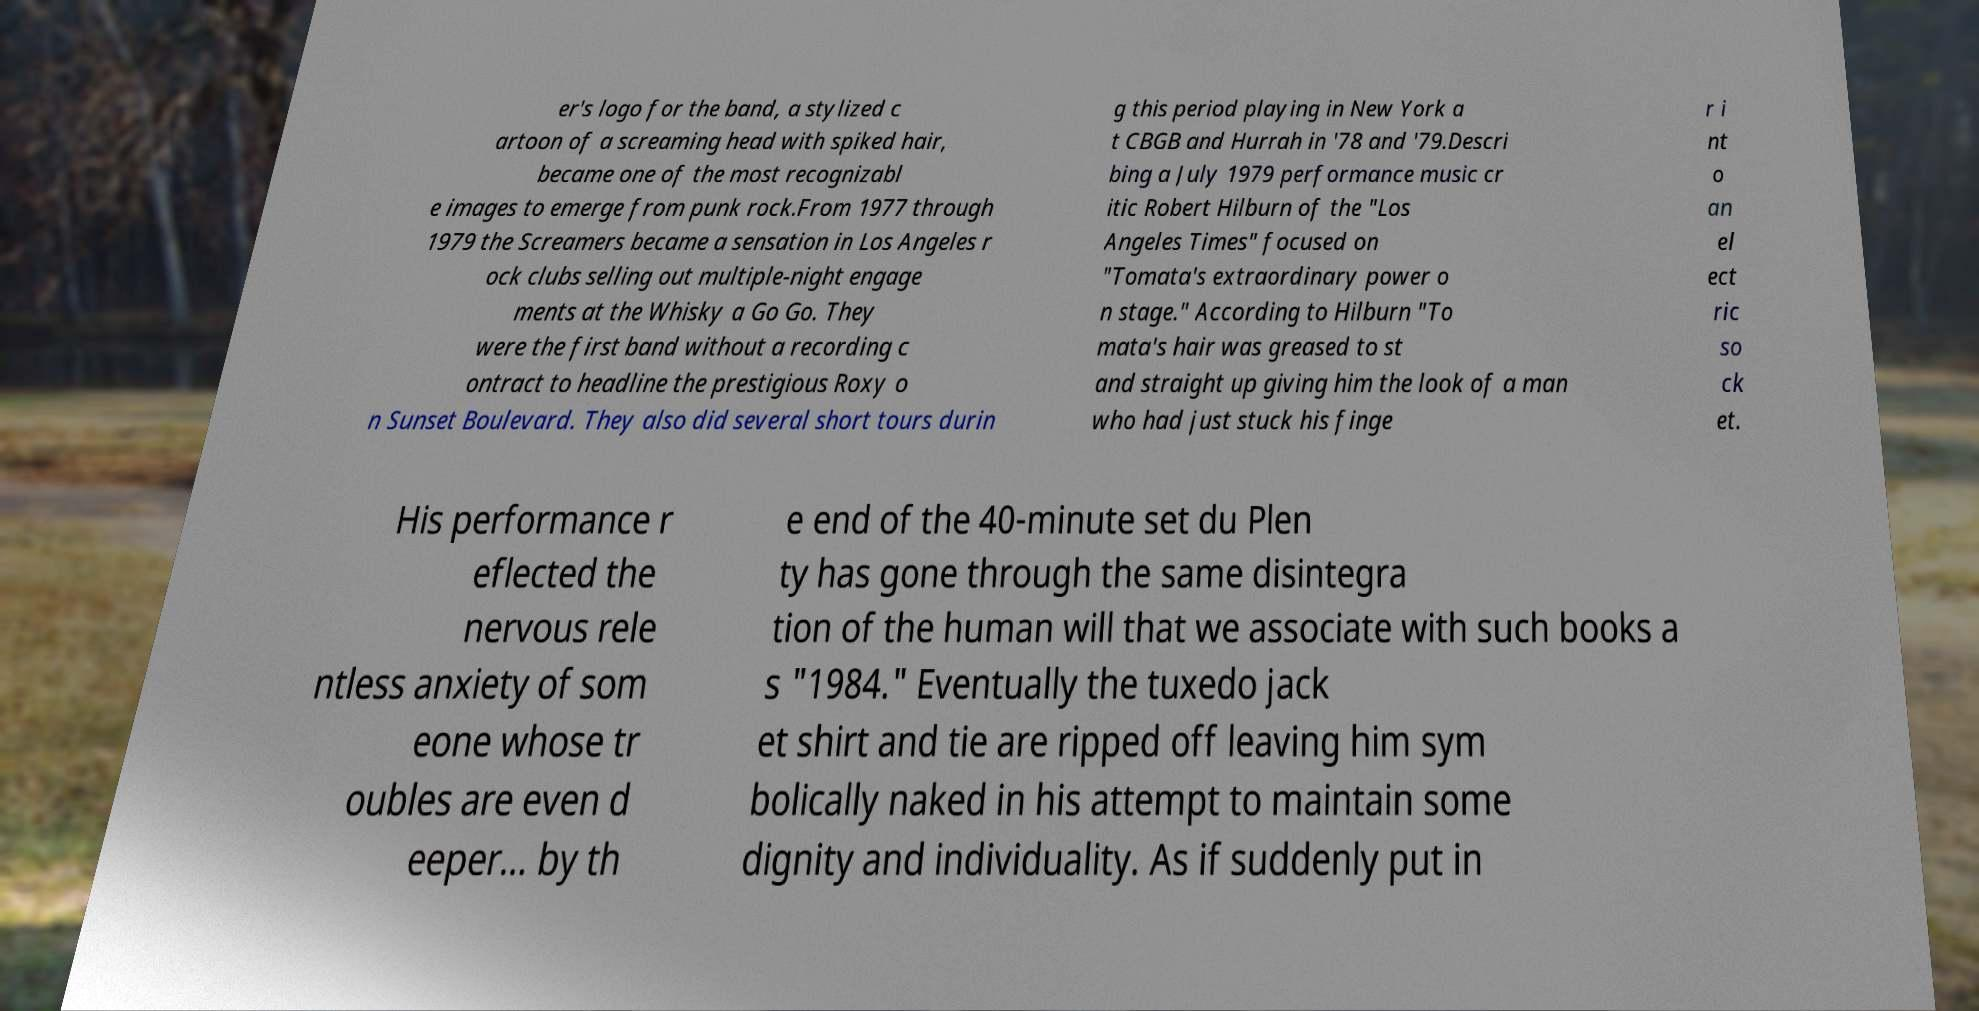Can you accurately transcribe the text from the provided image for me? er's logo for the band, a stylized c artoon of a screaming head with spiked hair, became one of the most recognizabl e images to emerge from punk rock.From 1977 through 1979 the Screamers became a sensation in Los Angeles r ock clubs selling out multiple-night engage ments at the Whisky a Go Go. They were the first band without a recording c ontract to headline the prestigious Roxy o n Sunset Boulevard. They also did several short tours durin g this period playing in New York a t CBGB and Hurrah in '78 and '79.Descri bing a July 1979 performance music cr itic Robert Hilburn of the "Los Angeles Times" focused on "Tomata's extraordinary power o n stage." According to Hilburn "To mata's hair was greased to st and straight up giving him the look of a man who had just stuck his finge r i nt o an el ect ric so ck et. His performance r eflected the nervous rele ntless anxiety of som eone whose tr oubles are even d eeper... by th e end of the 40-minute set du Plen ty has gone through the same disintegra tion of the human will that we associate with such books a s "1984." Eventually the tuxedo jack et shirt and tie are ripped off leaving him sym bolically naked in his attempt to maintain some dignity and individuality. As if suddenly put in 